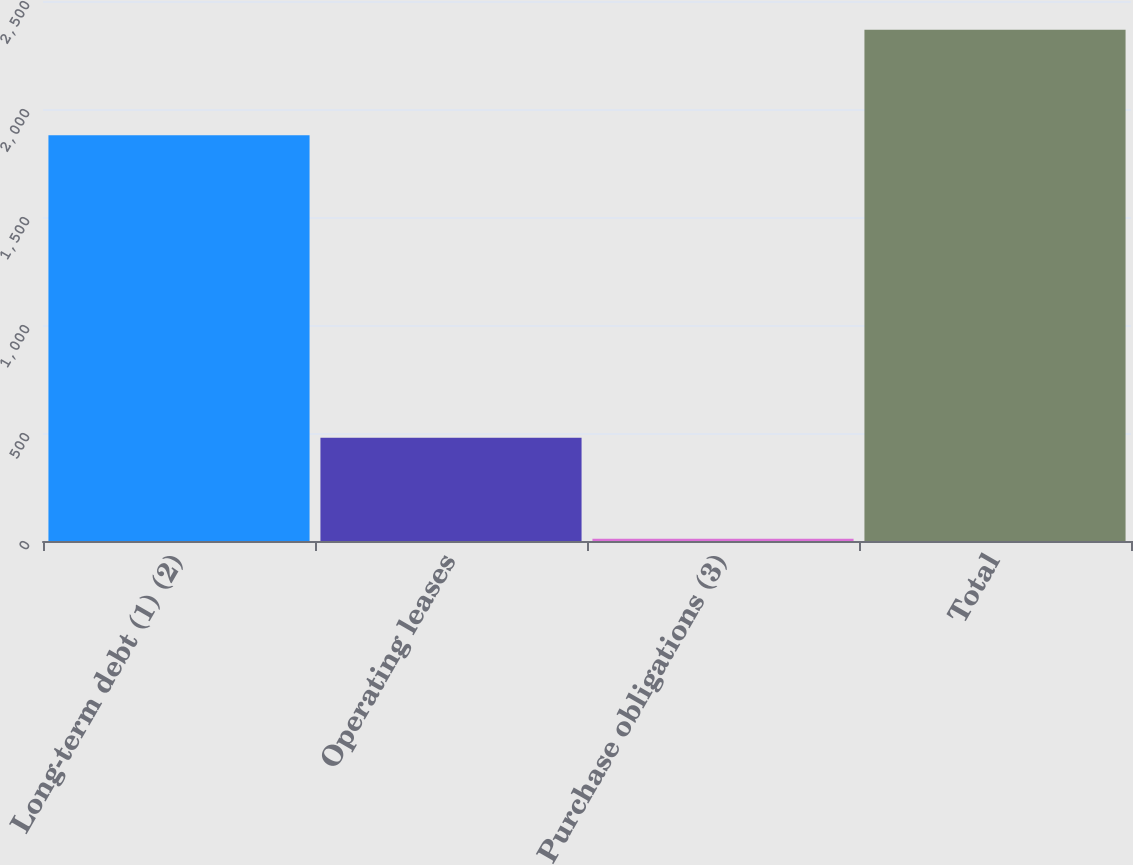<chart> <loc_0><loc_0><loc_500><loc_500><bar_chart><fcel>Long-term debt (1) (2)<fcel>Operating leases<fcel>Purchase obligations (3)<fcel>Total<nl><fcel>1879<fcel>478<fcel>10<fcel>2367<nl></chart> 